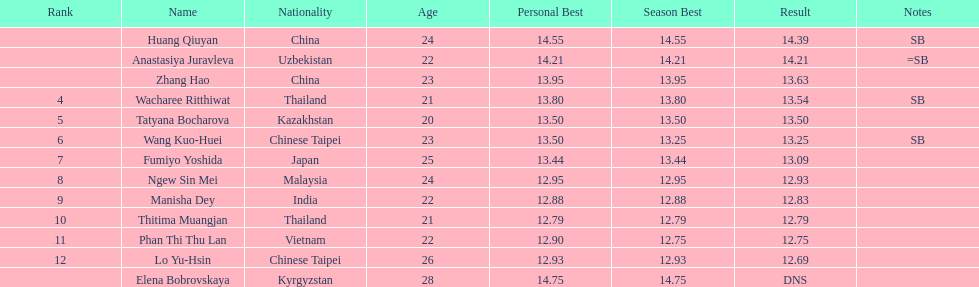What is the number of different nationalities represented by the top 5 athletes? 4. 